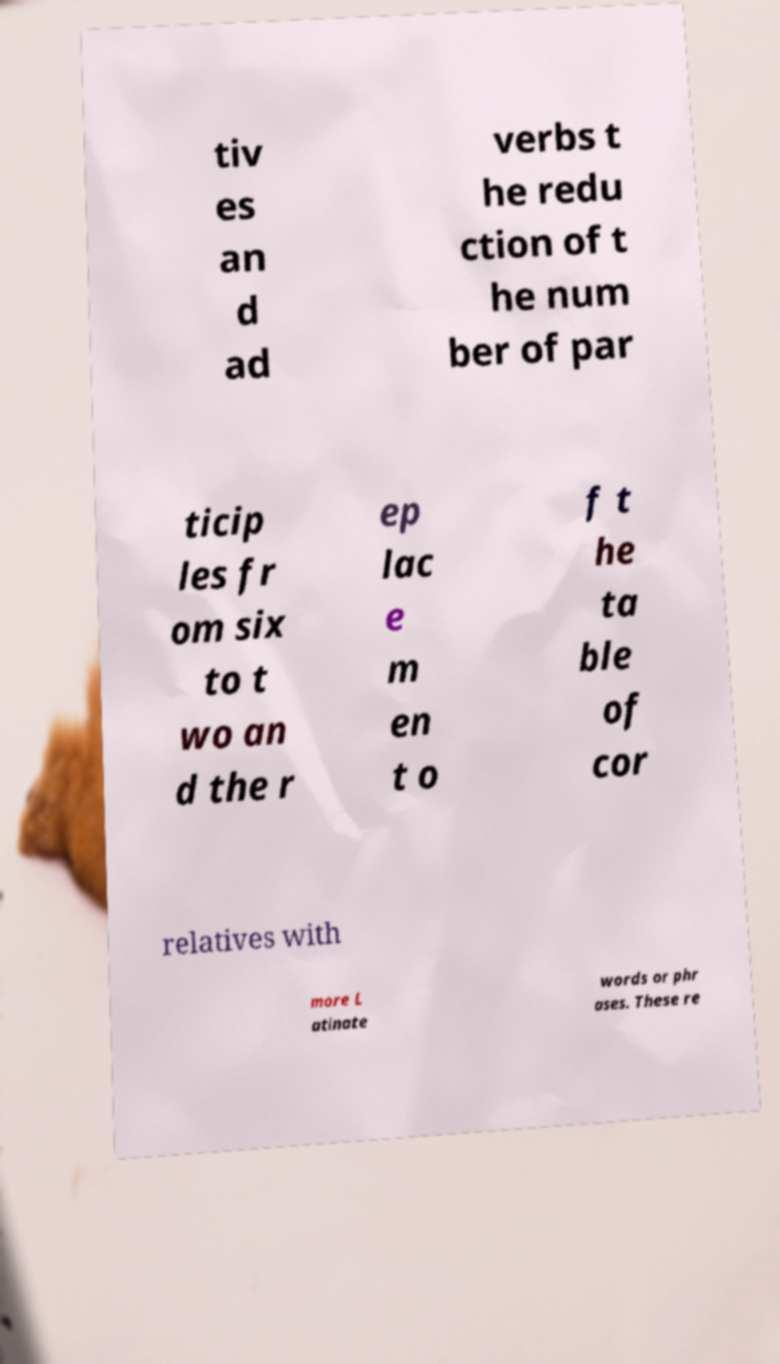What messages or text are displayed in this image? I need them in a readable, typed format. tiv es an d ad verbs t he redu ction of t he num ber of par ticip les fr om six to t wo an d the r ep lac e m en t o f t he ta ble of cor relatives with more L atinate words or phr ases. These re 